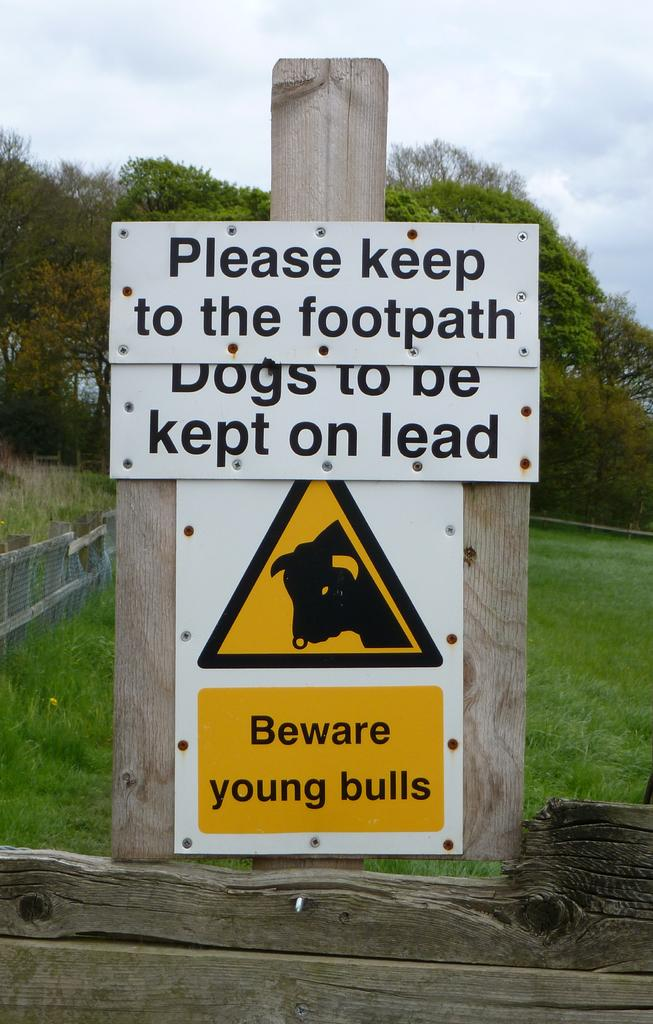What is attached to the wooden pole in the image? There is a board attached to a wooden pole in the image. What type of natural environment is visible in the background of the image? There is grass and plants in green color in the background of the image. How is the sky depicted in the image? The sky is in white color in the image. Can you see any examples of boats in the image? There are no boats present in the image. What type of scissors are being used to trim the plants in the image? There are no scissors or any trimming activity depicted in the image. 